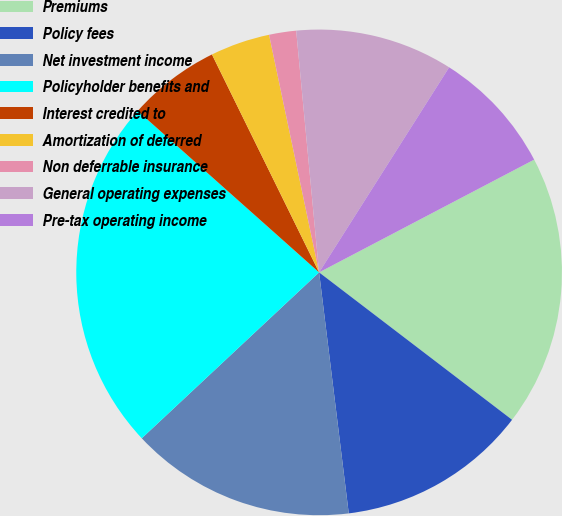Convert chart. <chart><loc_0><loc_0><loc_500><loc_500><pie_chart><fcel>Premiums<fcel>Policy fees<fcel>Net investment income<fcel>Policyholder benefits and<fcel>Interest credited to<fcel>Amortization of deferred<fcel>Non deferrable insurance<fcel>General operating expenses<fcel>Pre-tax operating income<nl><fcel>18.07%<fcel>12.67%<fcel>14.98%<fcel>23.55%<fcel>6.15%<fcel>3.97%<fcel>1.8%<fcel>10.5%<fcel>8.32%<nl></chart> 